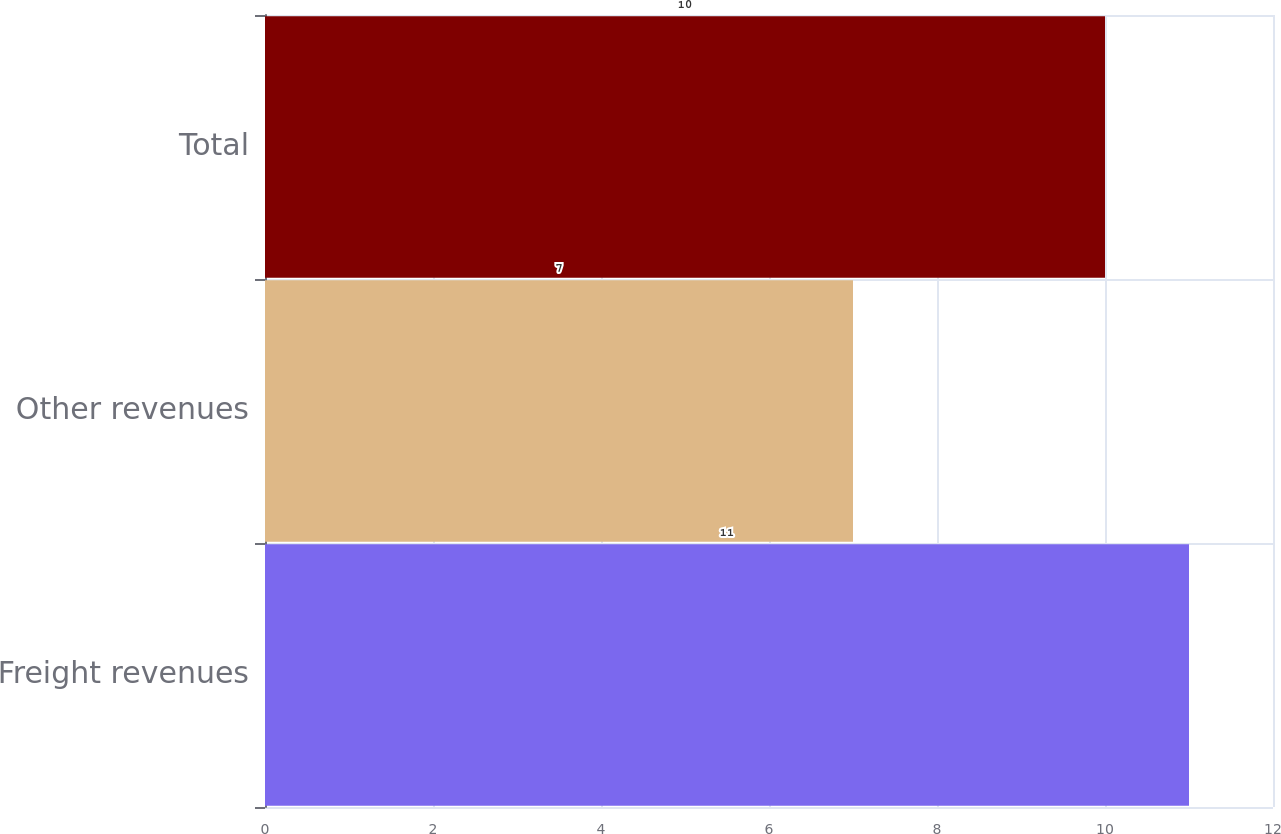Convert chart. <chart><loc_0><loc_0><loc_500><loc_500><bar_chart><fcel>Freight revenues<fcel>Other revenues<fcel>Total<nl><fcel>11<fcel>7<fcel>10<nl></chart> 